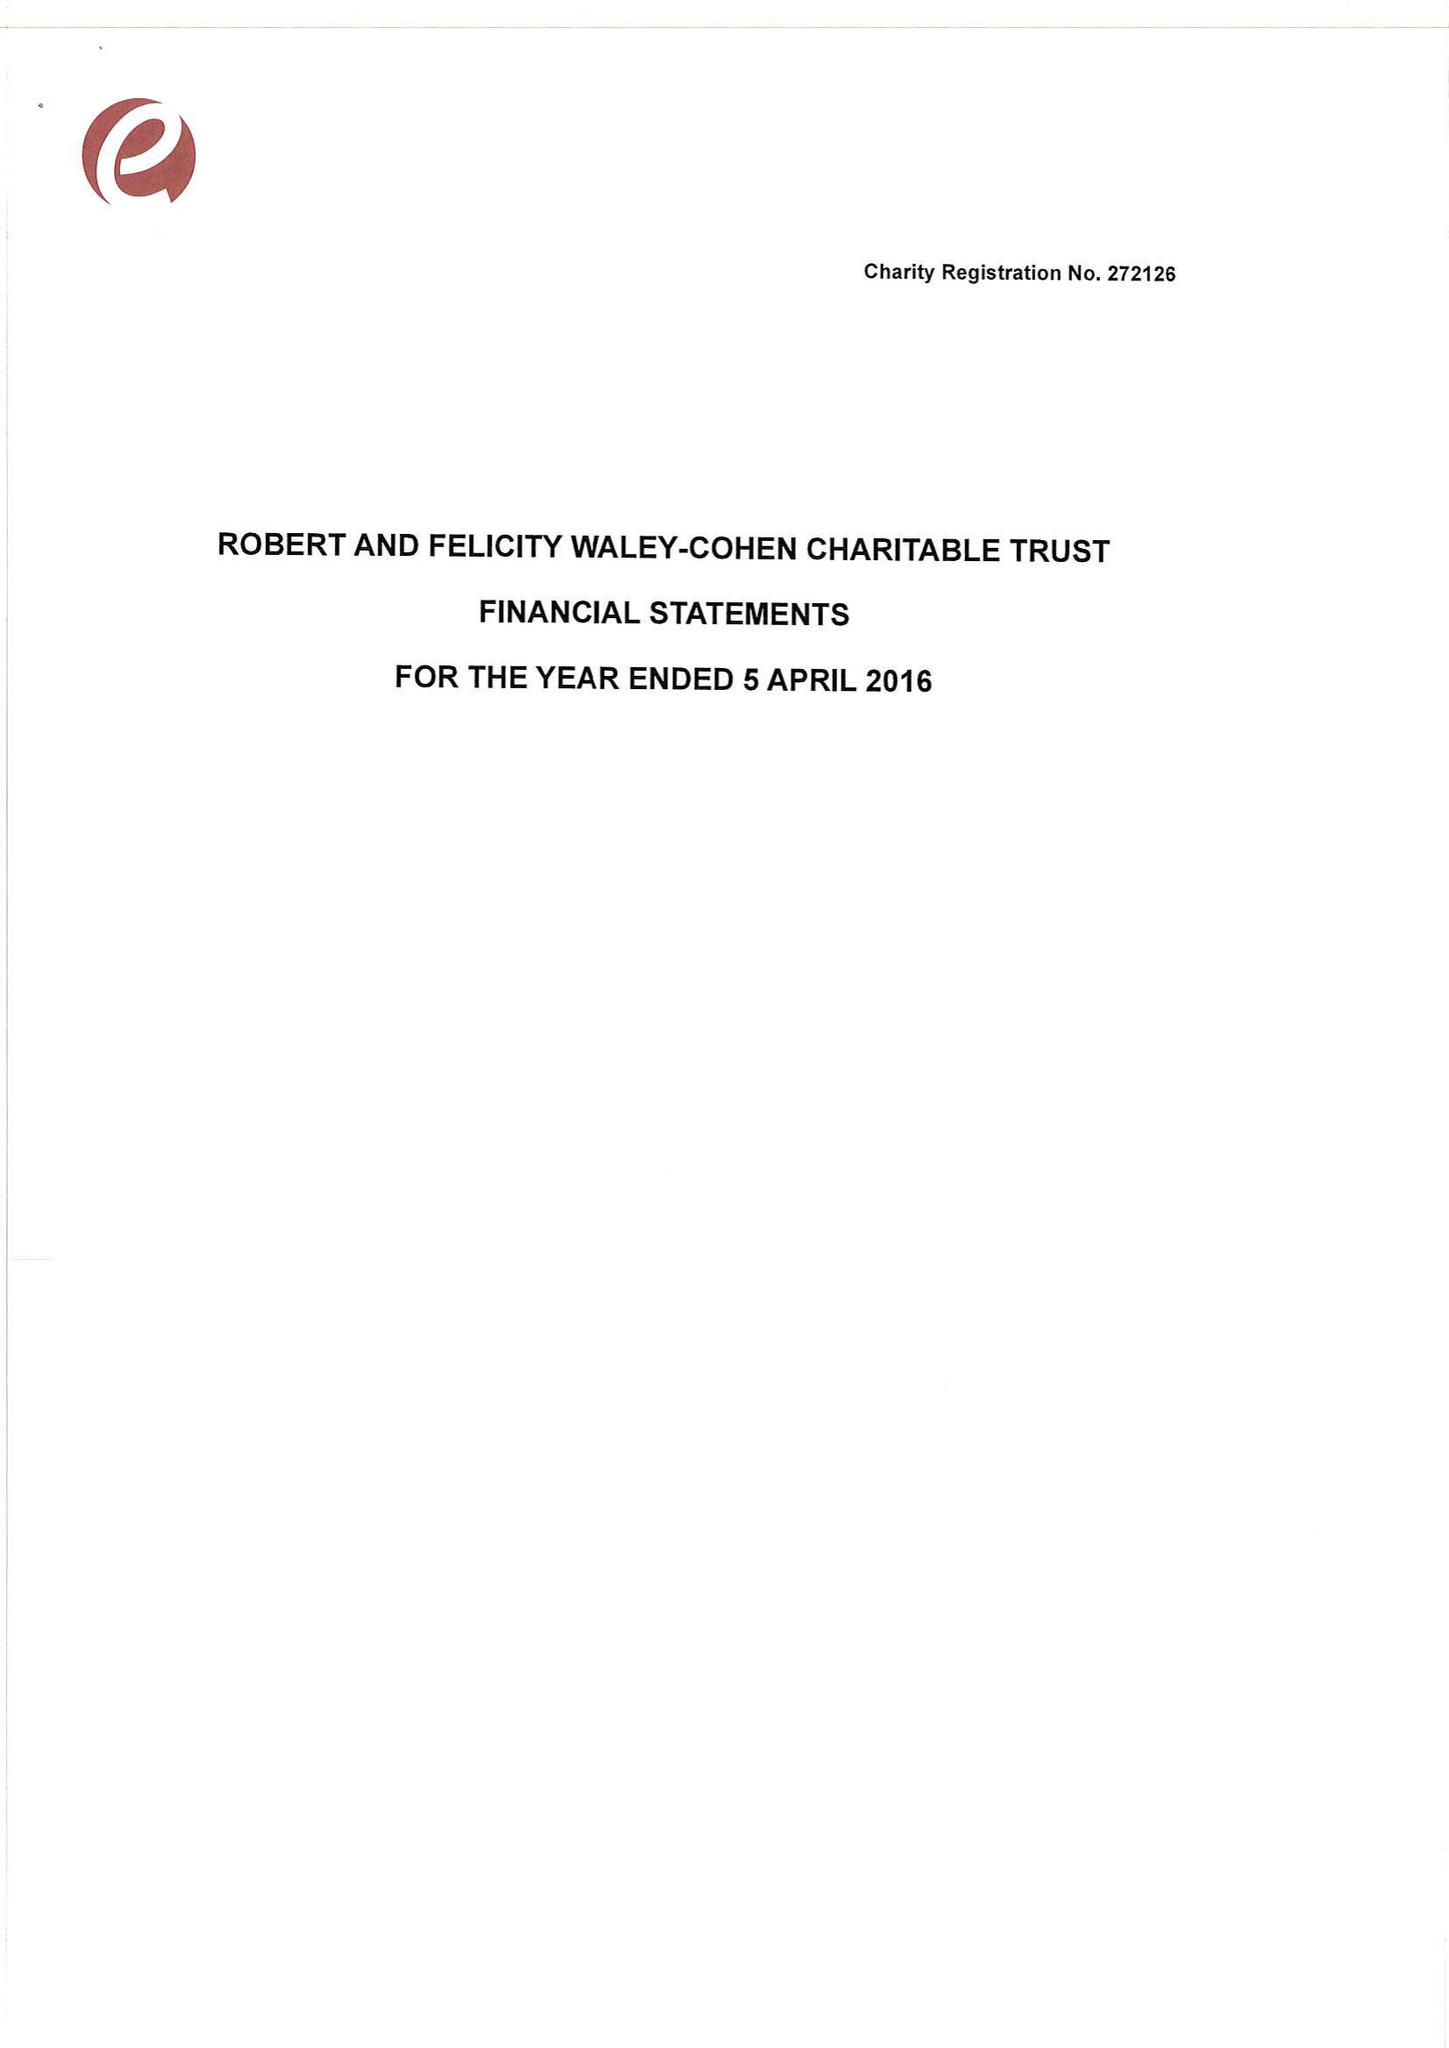What is the value for the charity_name?
Answer the question using a single word or phrase. Robert and Felicity Waley-Cohen Charitable Trust 